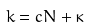Convert formula to latex. <formula><loc_0><loc_0><loc_500><loc_500>k = c N + \kappa</formula> 